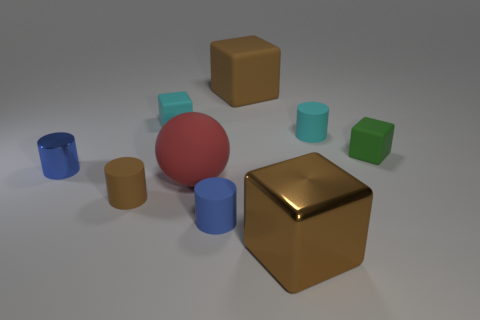There is a matte cylinder that is the same color as the big shiny object; what is its size?
Your answer should be very brief. Small. What number of things are either tiny rubber objects to the left of the green block or blue cubes?
Make the answer very short. 4. What material is the cyan cylinder?
Your answer should be compact. Rubber. Do the brown shiny cube and the cyan cylinder have the same size?
Give a very brief answer. No. How many balls are either small blue things or tiny blue metallic things?
Provide a succinct answer. 0. There is a tiny matte cylinder on the right side of the big rubber thing that is behind the tiny cyan rubber block; what color is it?
Make the answer very short. Cyan. Are there fewer rubber cylinders to the right of the large brown rubber thing than things that are in front of the tiny green object?
Offer a very short reply. Yes. There is a cyan matte cylinder; is its size the same as the blue cylinder in front of the small brown cylinder?
Offer a very short reply. Yes. There is a small thing that is on the left side of the metallic cube and behind the blue shiny thing; what is its shape?
Your answer should be very brief. Cube. What is the size of the green block that is made of the same material as the small cyan block?
Provide a succinct answer. Small. 